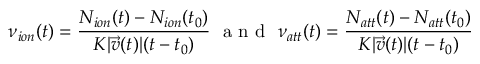Convert formula to latex. <formula><loc_0><loc_0><loc_500><loc_500>\nu _ { i o n } ( t ) = \frac { N _ { i o n } ( t ) - N _ { i o n } ( t _ { 0 } ) } { K | \vec { v } ( t ) | ( t - t _ { 0 } ) } \, a n d \, \nu _ { a t t } ( t ) = \frac { N _ { a t t } ( t ) - N _ { a t t } ( t _ { 0 } ) } { K | \vec { v } ( t ) | ( t - t _ { 0 } ) }</formula> 